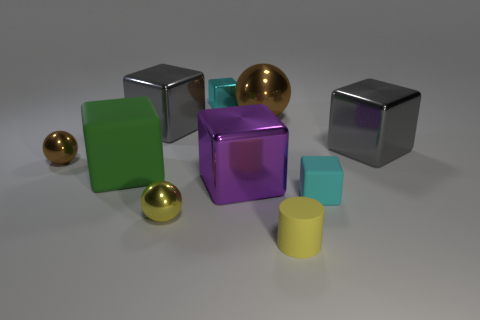How big is the yellow cylinder?
Ensure brevity in your answer.  Small. What number of yellow things have the same size as the green matte block?
Offer a very short reply. 0. What is the material of the big purple object that is the same shape as the large green object?
Give a very brief answer. Metal. There is a object that is both on the right side of the yellow shiny sphere and on the left side of the purple metallic cube; what shape is it?
Ensure brevity in your answer.  Cube. What shape is the matte thing that is to the left of the cyan shiny block?
Your response must be concise. Cube. How many metallic spheres are to the right of the large matte object and behind the purple block?
Keep it short and to the point. 1. Is the size of the cyan metallic cube the same as the gray metallic block right of the yellow cylinder?
Provide a short and direct response. No. How big is the sphere that is behind the large gray cube that is behind the big gray metal block that is on the right side of the yellow rubber cylinder?
Ensure brevity in your answer.  Large. There is a cyan block in front of the tiny brown sphere; how big is it?
Make the answer very short. Small. There is a large purple object that is the same material as the tiny brown thing; what is its shape?
Keep it short and to the point. Cube. 